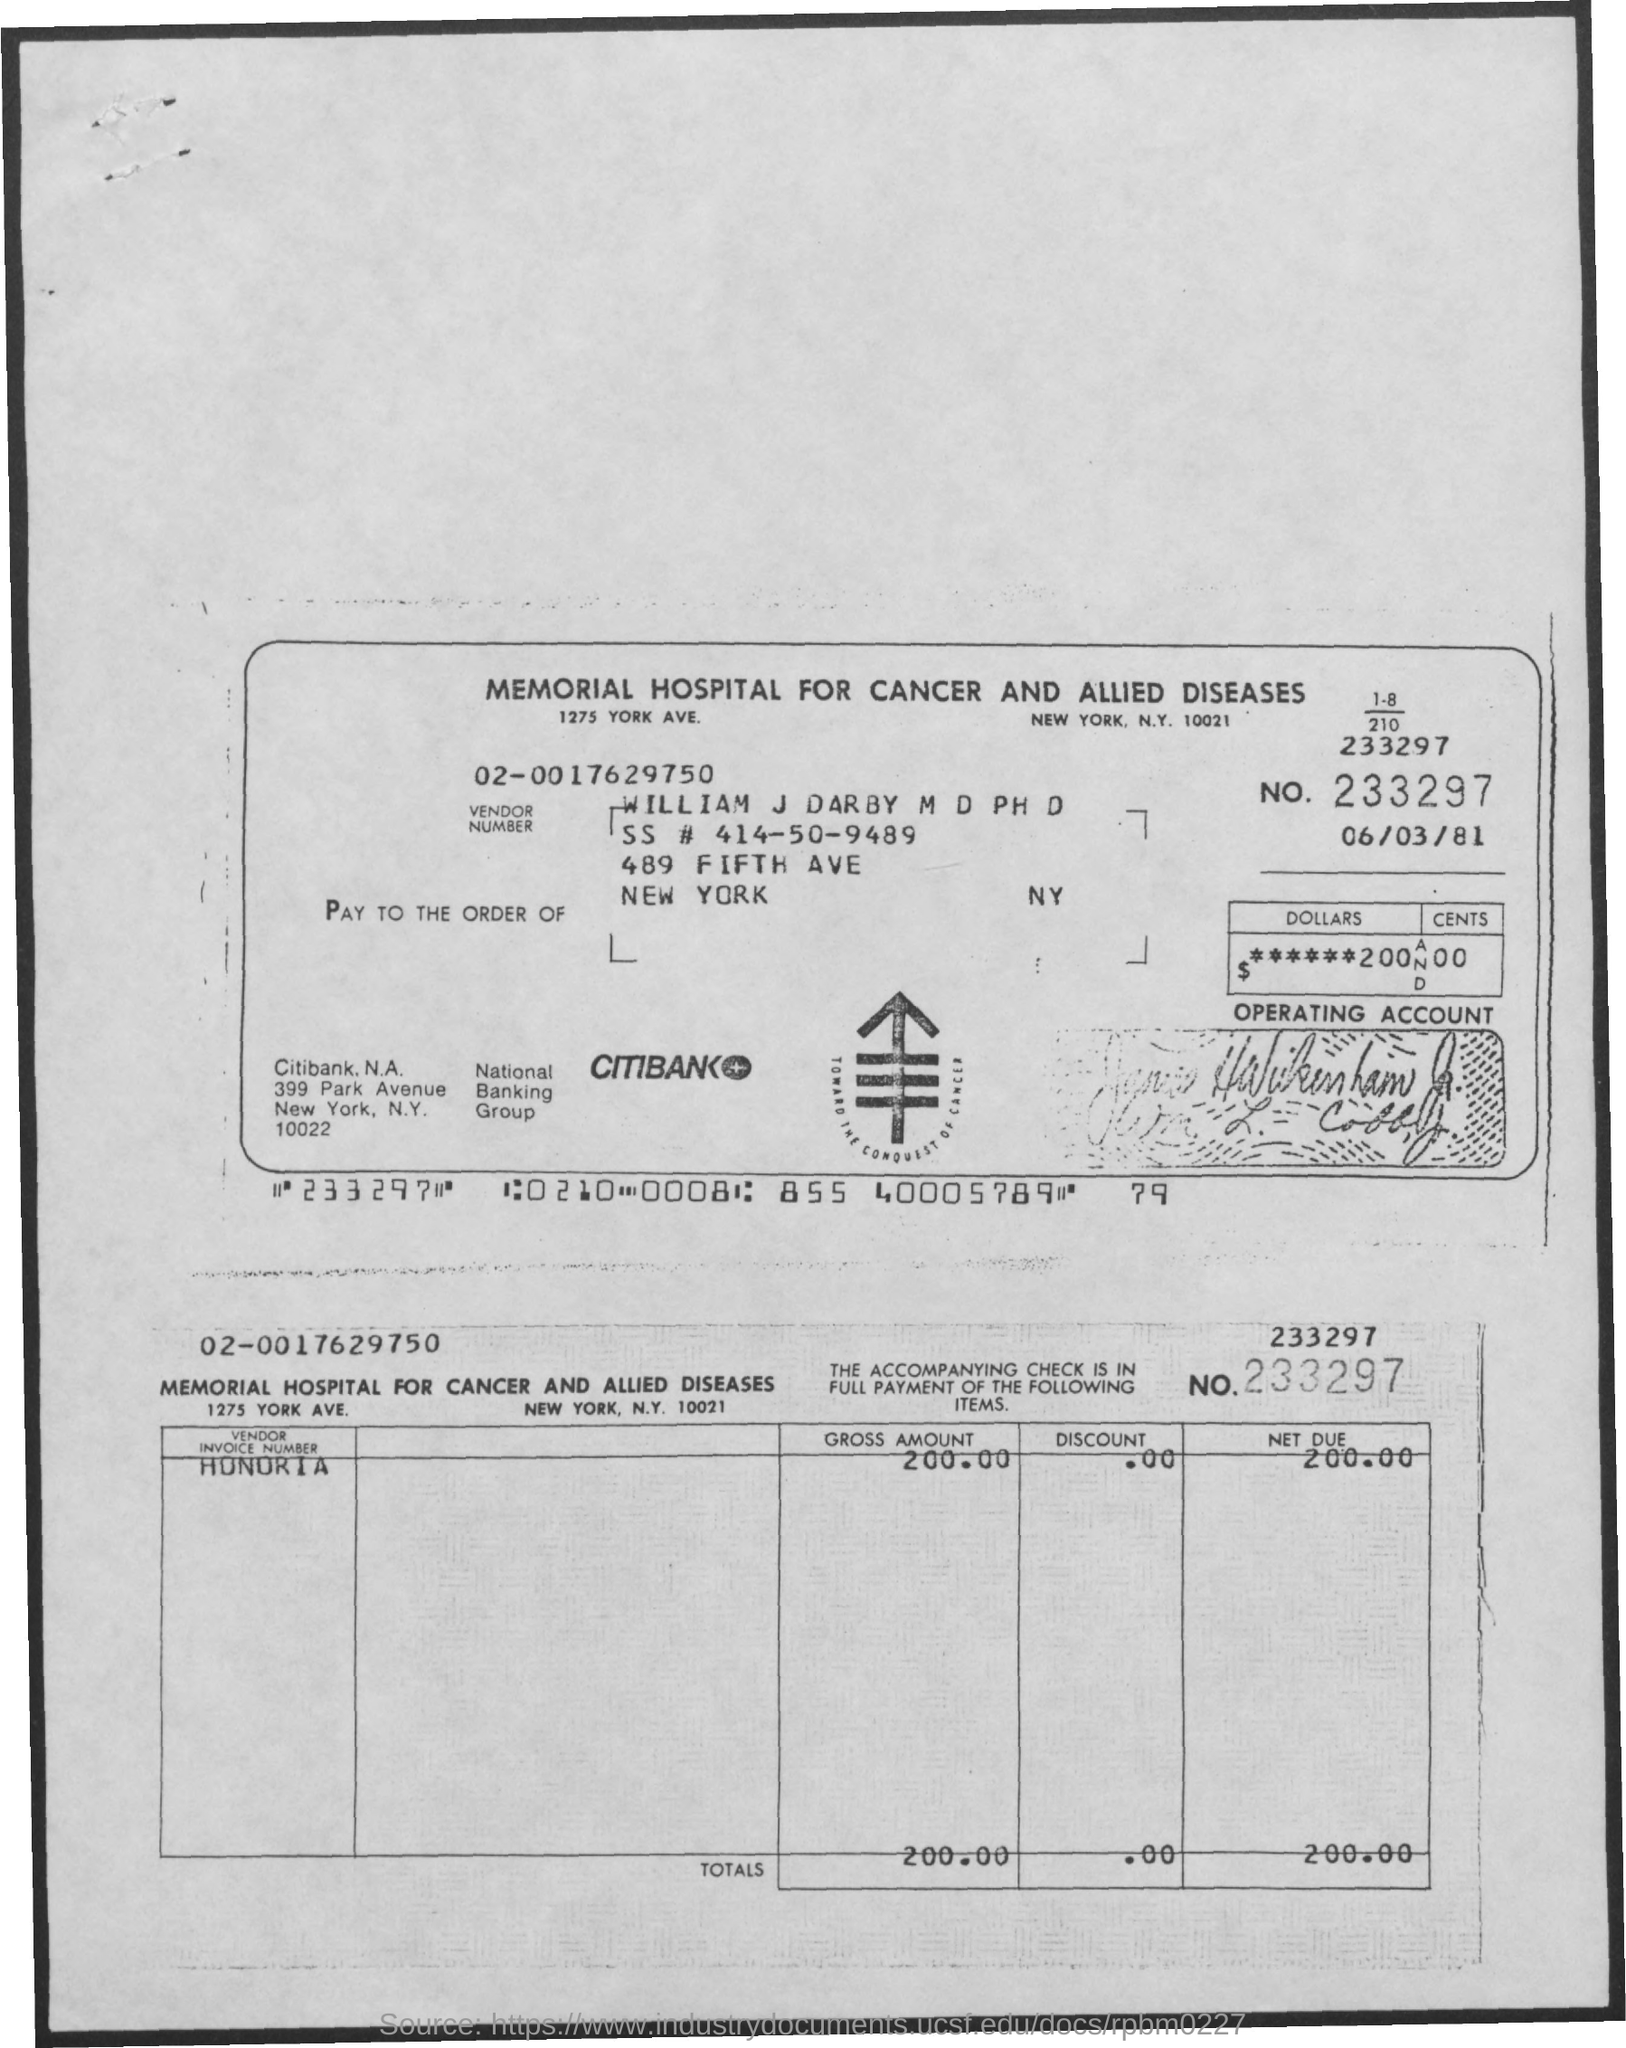Identify some key points in this picture. The name of the person is William J. Darby. The hospital is located in New York City. The due amount is 200.00. The total amount is 200.00. The name of the bank is CITIBANK. 